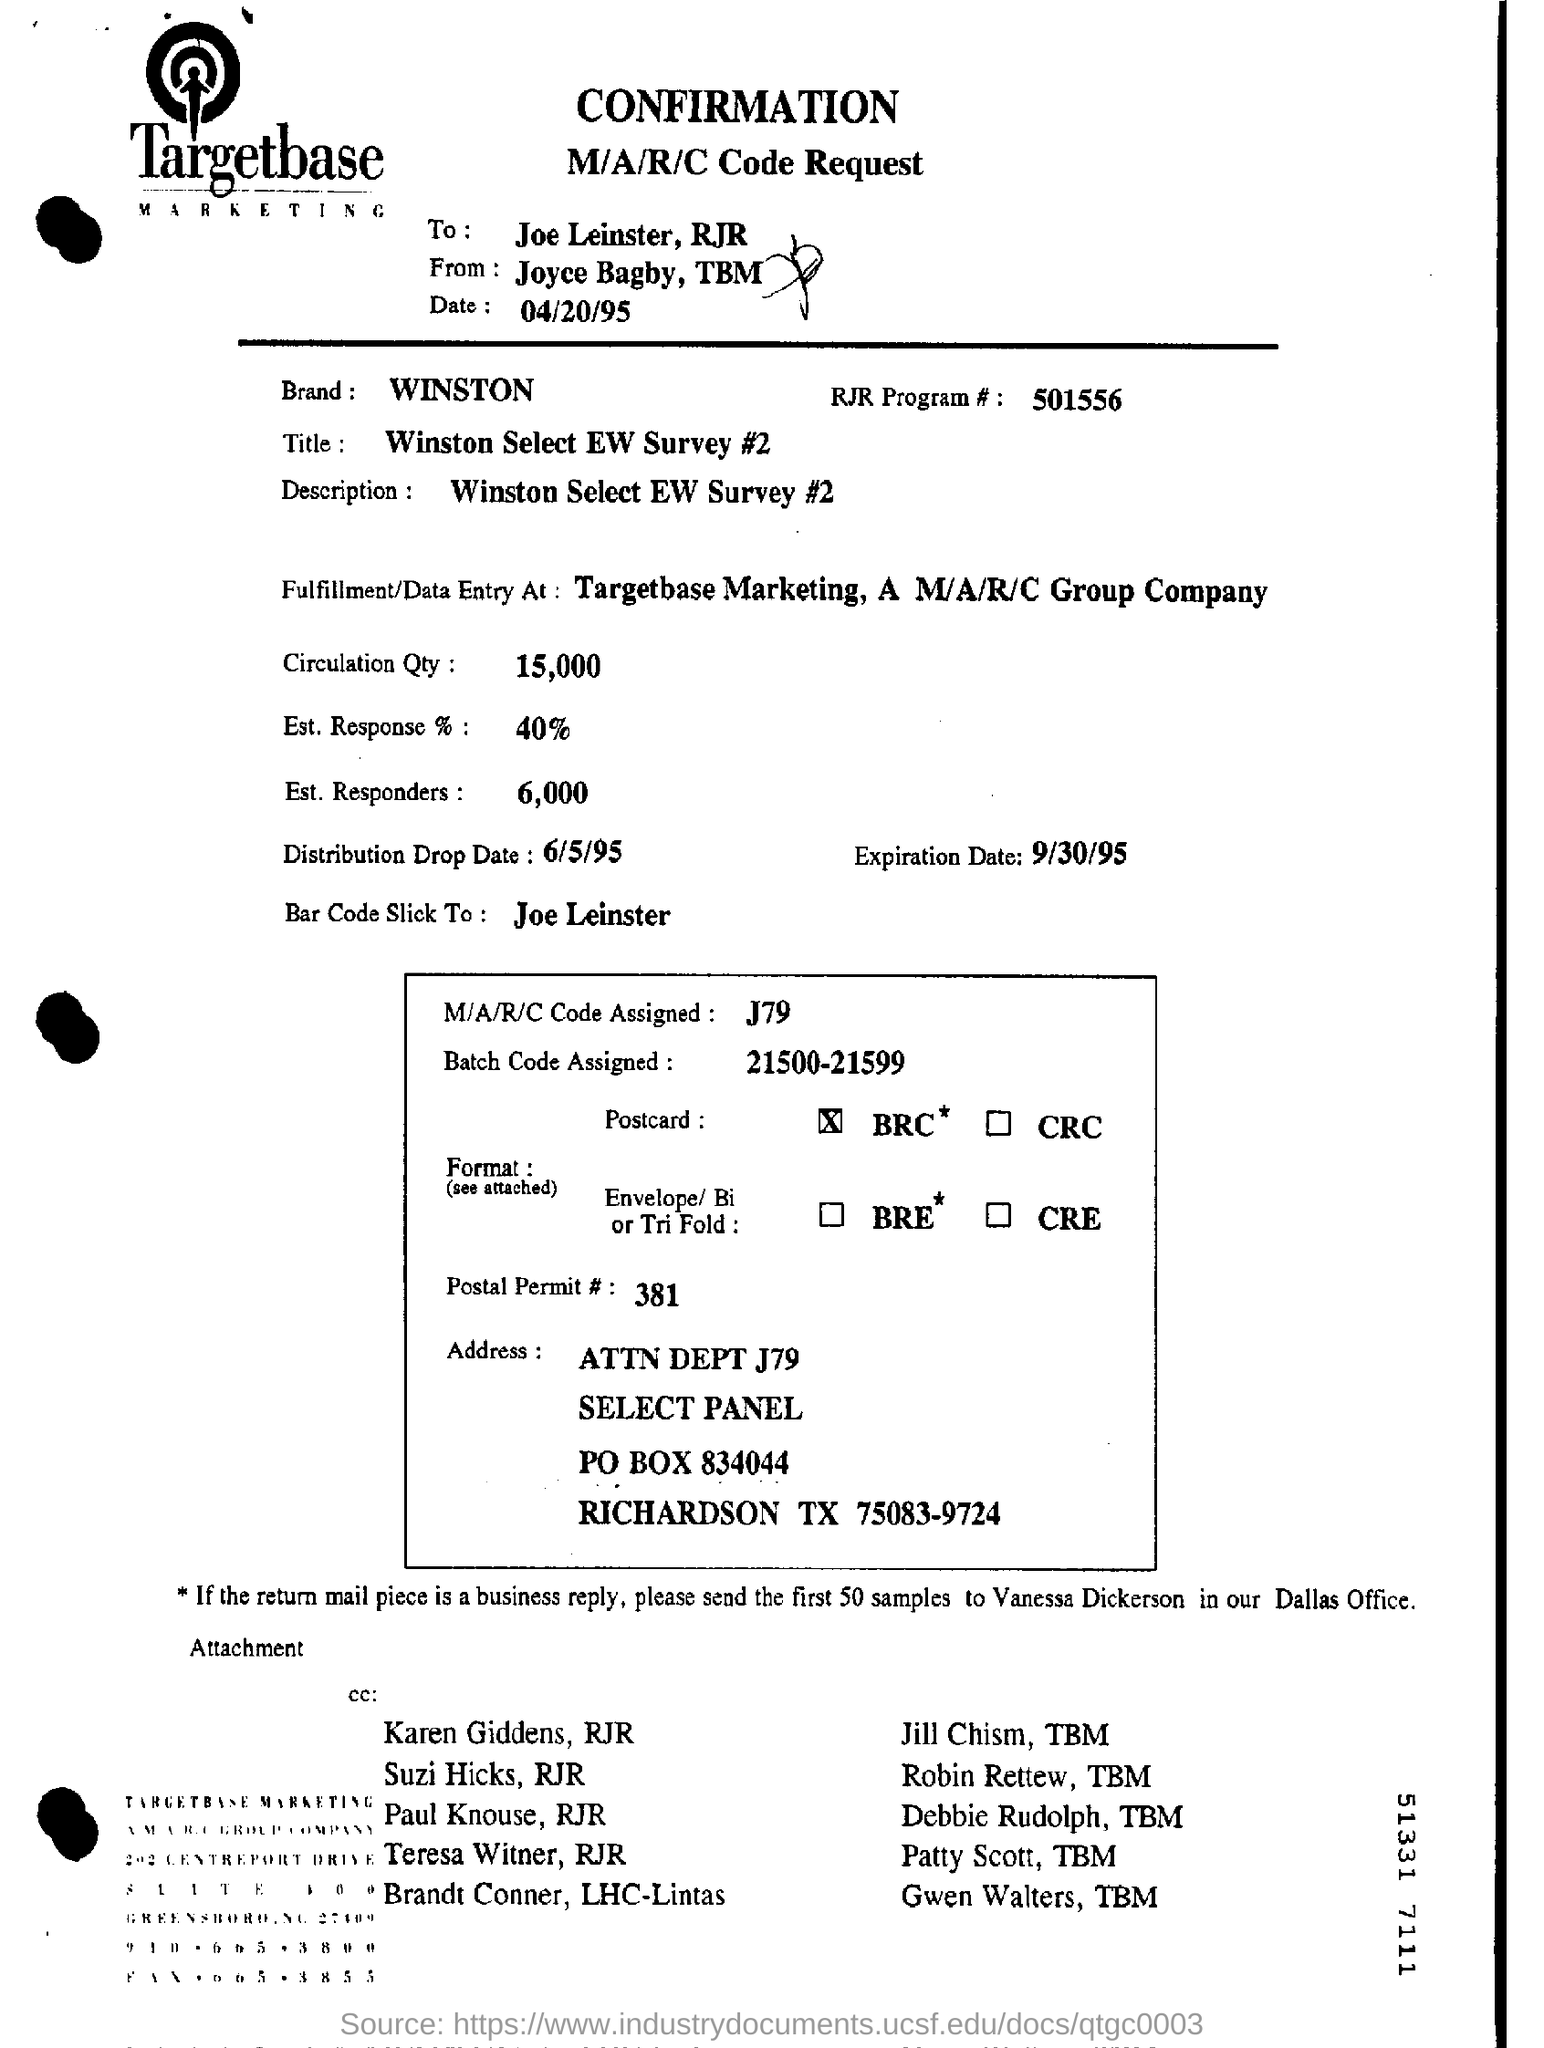Give some essential details in this illustration. The survey is titled Winston Select EW Survey #2. The batch code assigned is within the range of 21500-21599. The estimated number of responders is approximately 6000. The Circulation Quantity is 15,000. The expiration date of "What is the Expiration Date? 9/30/95.." is September 30, 1995. 